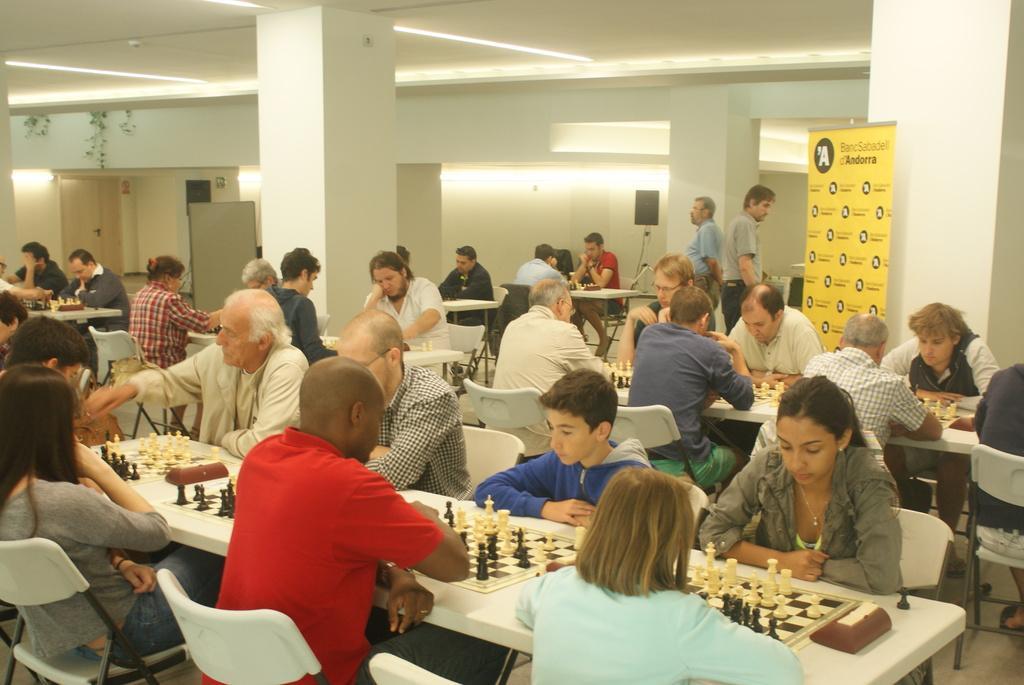Please provide a concise description of this image. In the image we can see there are lot of people who are sitting and on the table there are chess board and coins. 